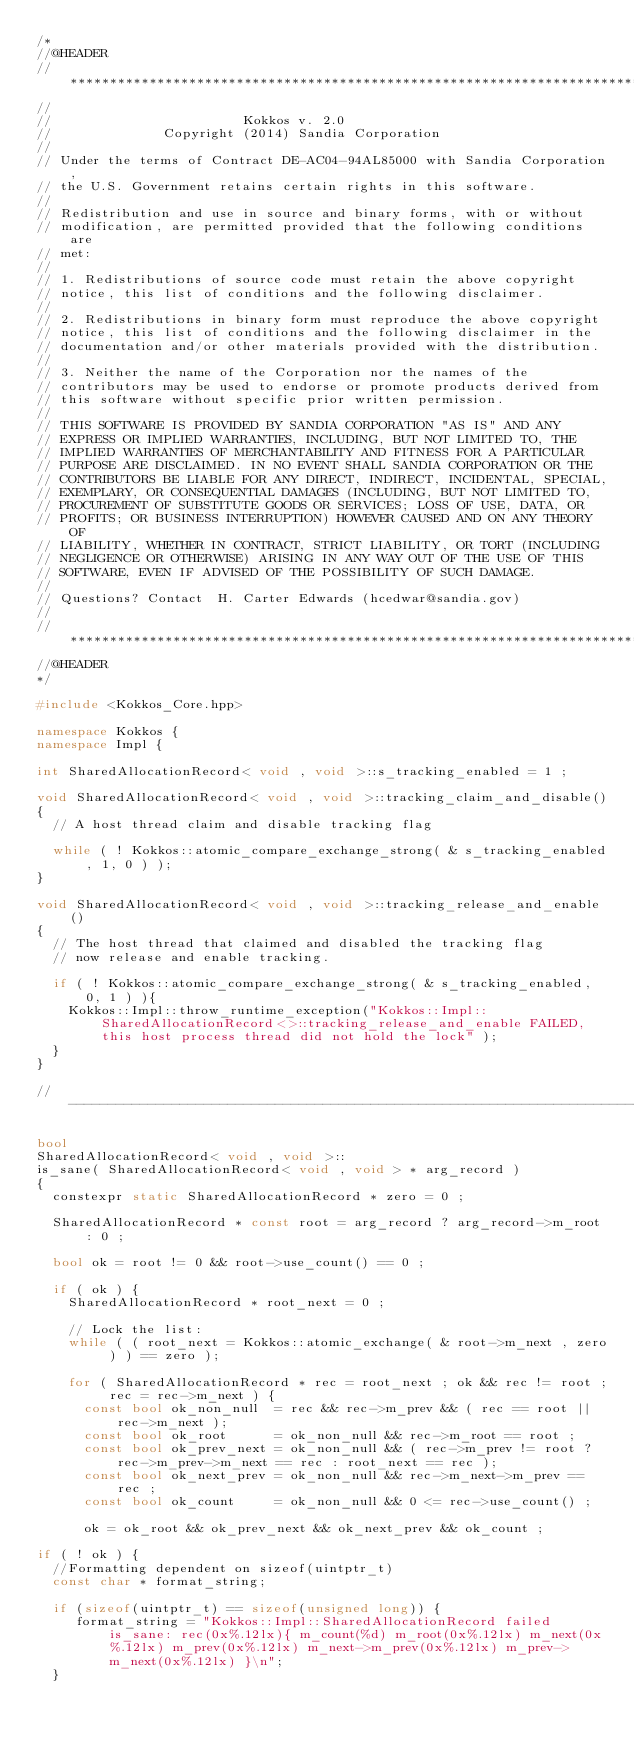Convert code to text. <code><loc_0><loc_0><loc_500><loc_500><_C++_>/*
//@HEADER
// ************************************************************************
// 
//                        Kokkos v. 2.0
//              Copyright (2014) Sandia Corporation
// 
// Under the terms of Contract DE-AC04-94AL85000 with Sandia Corporation,
// the U.S. Government retains certain rights in this software.
// 
// Redistribution and use in source and binary forms, with or without
// modification, are permitted provided that the following conditions are
// met:
//
// 1. Redistributions of source code must retain the above copyright
// notice, this list of conditions and the following disclaimer.
//
// 2. Redistributions in binary form must reproduce the above copyright
// notice, this list of conditions and the following disclaimer in the
// documentation and/or other materials provided with the distribution.
//
// 3. Neither the name of the Corporation nor the names of the
// contributors may be used to endorse or promote products derived from
// this software without specific prior written permission.
//
// THIS SOFTWARE IS PROVIDED BY SANDIA CORPORATION "AS IS" AND ANY
// EXPRESS OR IMPLIED WARRANTIES, INCLUDING, BUT NOT LIMITED TO, THE
// IMPLIED WARRANTIES OF MERCHANTABILITY AND FITNESS FOR A PARTICULAR
// PURPOSE ARE DISCLAIMED. IN NO EVENT SHALL SANDIA CORPORATION OR THE
// CONTRIBUTORS BE LIABLE FOR ANY DIRECT, INDIRECT, INCIDENTAL, SPECIAL,
// EXEMPLARY, OR CONSEQUENTIAL DAMAGES (INCLUDING, BUT NOT LIMITED TO,
// PROCUREMENT OF SUBSTITUTE GOODS OR SERVICES; LOSS OF USE, DATA, OR
// PROFITS; OR BUSINESS INTERRUPTION) HOWEVER CAUSED AND ON ANY THEORY OF
// LIABILITY, WHETHER IN CONTRACT, STRICT LIABILITY, OR TORT (INCLUDING
// NEGLIGENCE OR OTHERWISE) ARISING IN ANY WAY OUT OF THE USE OF THIS
// SOFTWARE, EVEN IF ADVISED OF THE POSSIBILITY OF SUCH DAMAGE.
//
// Questions? Contact  H. Carter Edwards (hcedwar@sandia.gov)
// 
// ************************************************************************
//@HEADER
*/

#include <Kokkos_Core.hpp>

namespace Kokkos {
namespace Impl {

int SharedAllocationRecord< void , void >::s_tracking_enabled = 1 ;

void SharedAllocationRecord< void , void >::tracking_claim_and_disable()
{
  // A host thread claim and disable tracking flag

  while ( ! Kokkos::atomic_compare_exchange_strong( & s_tracking_enabled, 1, 0 ) );
}

void SharedAllocationRecord< void , void >::tracking_release_and_enable()
{
  // The host thread that claimed and disabled the tracking flag
  // now release and enable tracking.

  if ( ! Kokkos::atomic_compare_exchange_strong( & s_tracking_enabled, 0, 1 ) ){
    Kokkos::Impl::throw_runtime_exception("Kokkos::Impl::SharedAllocationRecord<>::tracking_release_and_enable FAILED, this host process thread did not hold the lock" );
  }
}

//----------------------------------------------------------------------------

bool
SharedAllocationRecord< void , void >::
is_sane( SharedAllocationRecord< void , void > * arg_record )
{
  constexpr static SharedAllocationRecord * zero = 0 ;

  SharedAllocationRecord * const root = arg_record ? arg_record->m_root : 0 ;

  bool ok = root != 0 && root->use_count() == 0 ;

  if ( ok ) {
    SharedAllocationRecord * root_next = 0 ;

    // Lock the list:
    while ( ( root_next = Kokkos::atomic_exchange( & root->m_next , zero ) ) == zero );

    for ( SharedAllocationRecord * rec = root_next ; ok && rec != root ; rec = rec->m_next ) {
      const bool ok_non_null  = rec && rec->m_prev && ( rec == root || rec->m_next );
      const bool ok_root      = ok_non_null && rec->m_root == root ;
      const bool ok_prev_next = ok_non_null && ( rec->m_prev != root ? rec->m_prev->m_next == rec : root_next == rec );
      const bool ok_next_prev = ok_non_null && rec->m_next->m_prev == rec ;
      const bool ok_count     = ok_non_null && 0 <= rec->use_count() ;

      ok = ok_root && ok_prev_next && ok_next_prev && ok_count ;

if ( ! ok ) {
  //Formatting dependent on sizeof(uintptr_t) 
  const char * format_string;
  
  if (sizeof(uintptr_t) == sizeof(unsigned long)) {
     format_string = "Kokkos::Impl::SharedAllocationRecord failed is_sane: rec(0x%.12lx){ m_count(%d) m_root(0x%.12lx) m_next(0x%.12lx) m_prev(0x%.12lx) m_next->m_prev(0x%.12lx) m_prev->m_next(0x%.12lx) }\n";
  }</code> 